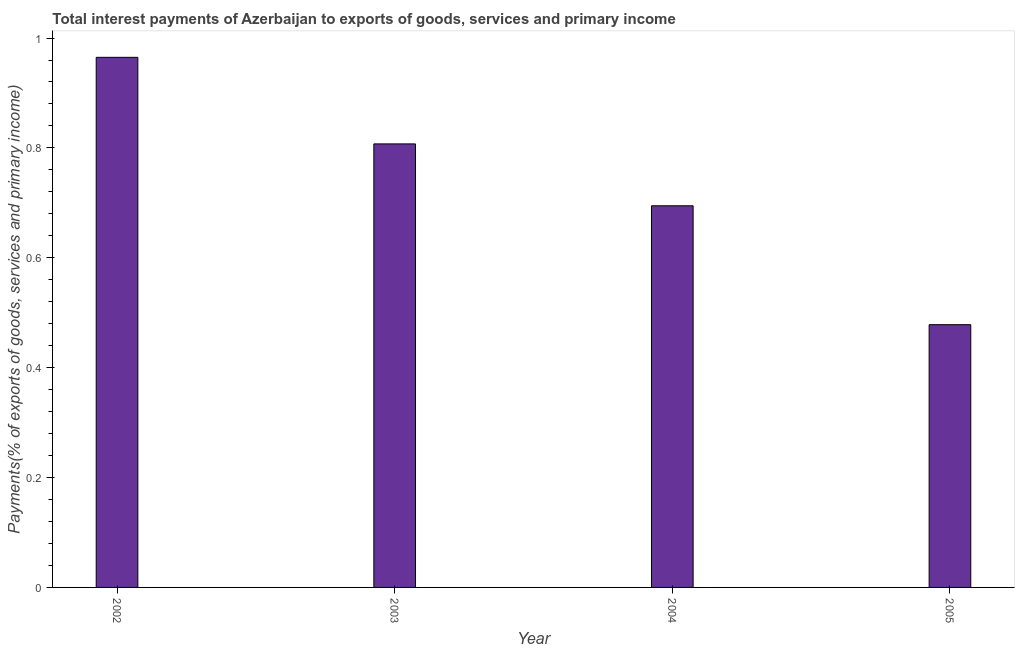Does the graph contain any zero values?
Offer a terse response. No. What is the title of the graph?
Provide a succinct answer. Total interest payments of Azerbaijan to exports of goods, services and primary income. What is the label or title of the X-axis?
Keep it short and to the point. Year. What is the label or title of the Y-axis?
Offer a very short reply. Payments(% of exports of goods, services and primary income). What is the total interest payments on external debt in 2003?
Your answer should be very brief. 0.81. Across all years, what is the maximum total interest payments on external debt?
Make the answer very short. 0.96. Across all years, what is the minimum total interest payments on external debt?
Offer a terse response. 0.48. What is the sum of the total interest payments on external debt?
Keep it short and to the point. 2.95. What is the difference between the total interest payments on external debt in 2003 and 2004?
Provide a short and direct response. 0.11. What is the average total interest payments on external debt per year?
Give a very brief answer. 0.74. What is the median total interest payments on external debt?
Your answer should be compact. 0.75. In how many years, is the total interest payments on external debt greater than 0.6 %?
Offer a terse response. 3. What is the ratio of the total interest payments on external debt in 2003 to that in 2005?
Ensure brevity in your answer.  1.69. Is the total interest payments on external debt in 2002 less than that in 2005?
Provide a short and direct response. No. What is the difference between the highest and the second highest total interest payments on external debt?
Ensure brevity in your answer.  0.16. What is the difference between the highest and the lowest total interest payments on external debt?
Offer a very short reply. 0.49. How many years are there in the graph?
Keep it short and to the point. 4. What is the Payments(% of exports of goods, services and primary income) in 2002?
Ensure brevity in your answer.  0.96. What is the Payments(% of exports of goods, services and primary income) in 2003?
Provide a short and direct response. 0.81. What is the Payments(% of exports of goods, services and primary income) of 2004?
Provide a succinct answer. 0.69. What is the Payments(% of exports of goods, services and primary income) in 2005?
Keep it short and to the point. 0.48. What is the difference between the Payments(% of exports of goods, services and primary income) in 2002 and 2003?
Ensure brevity in your answer.  0.16. What is the difference between the Payments(% of exports of goods, services and primary income) in 2002 and 2004?
Offer a very short reply. 0.27. What is the difference between the Payments(% of exports of goods, services and primary income) in 2002 and 2005?
Offer a very short reply. 0.49. What is the difference between the Payments(% of exports of goods, services and primary income) in 2003 and 2004?
Ensure brevity in your answer.  0.11. What is the difference between the Payments(% of exports of goods, services and primary income) in 2003 and 2005?
Make the answer very short. 0.33. What is the difference between the Payments(% of exports of goods, services and primary income) in 2004 and 2005?
Provide a succinct answer. 0.22. What is the ratio of the Payments(% of exports of goods, services and primary income) in 2002 to that in 2003?
Provide a succinct answer. 1.2. What is the ratio of the Payments(% of exports of goods, services and primary income) in 2002 to that in 2004?
Keep it short and to the point. 1.39. What is the ratio of the Payments(% of exports of goods, services and primary income) in 2002 to that in 2005?
Make the answer very short. 2.02. What is the ratio of the Payments(% of exports of goods, services and primary income) in 2003 to that in 2004?
Offer a very short reply. 1.16. What is the ratio of the Payments(% of exports of goods, services and primary income) in 2003 to that in 2005?
Provide a short and direct response. 1.69. What is the ratio of the Payments(% of exports of goods, services and primary income) in 2004 to that in 2005?
Provide a succinct answer. 1.45. 